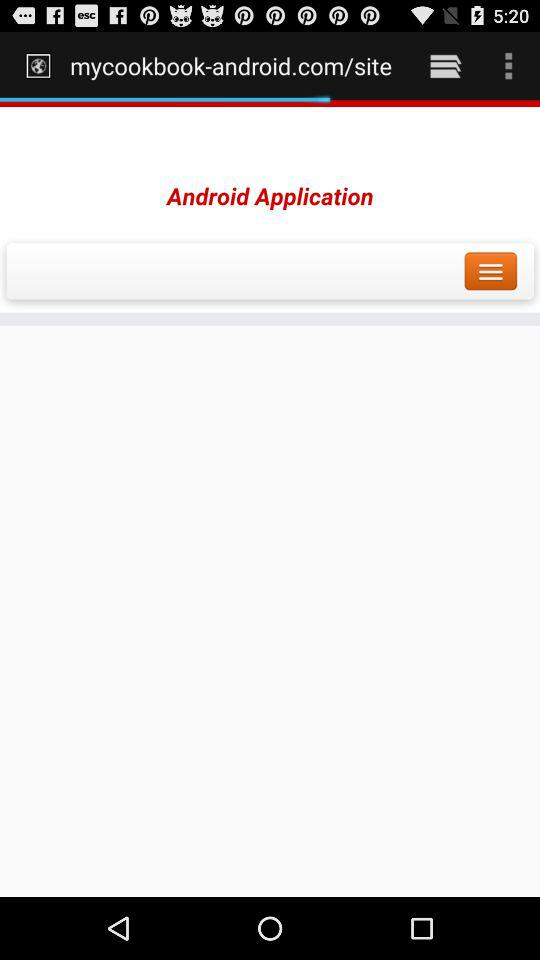What is the name of application?
When the provided information is insufficient, respond with <no answer>. <no answer> 